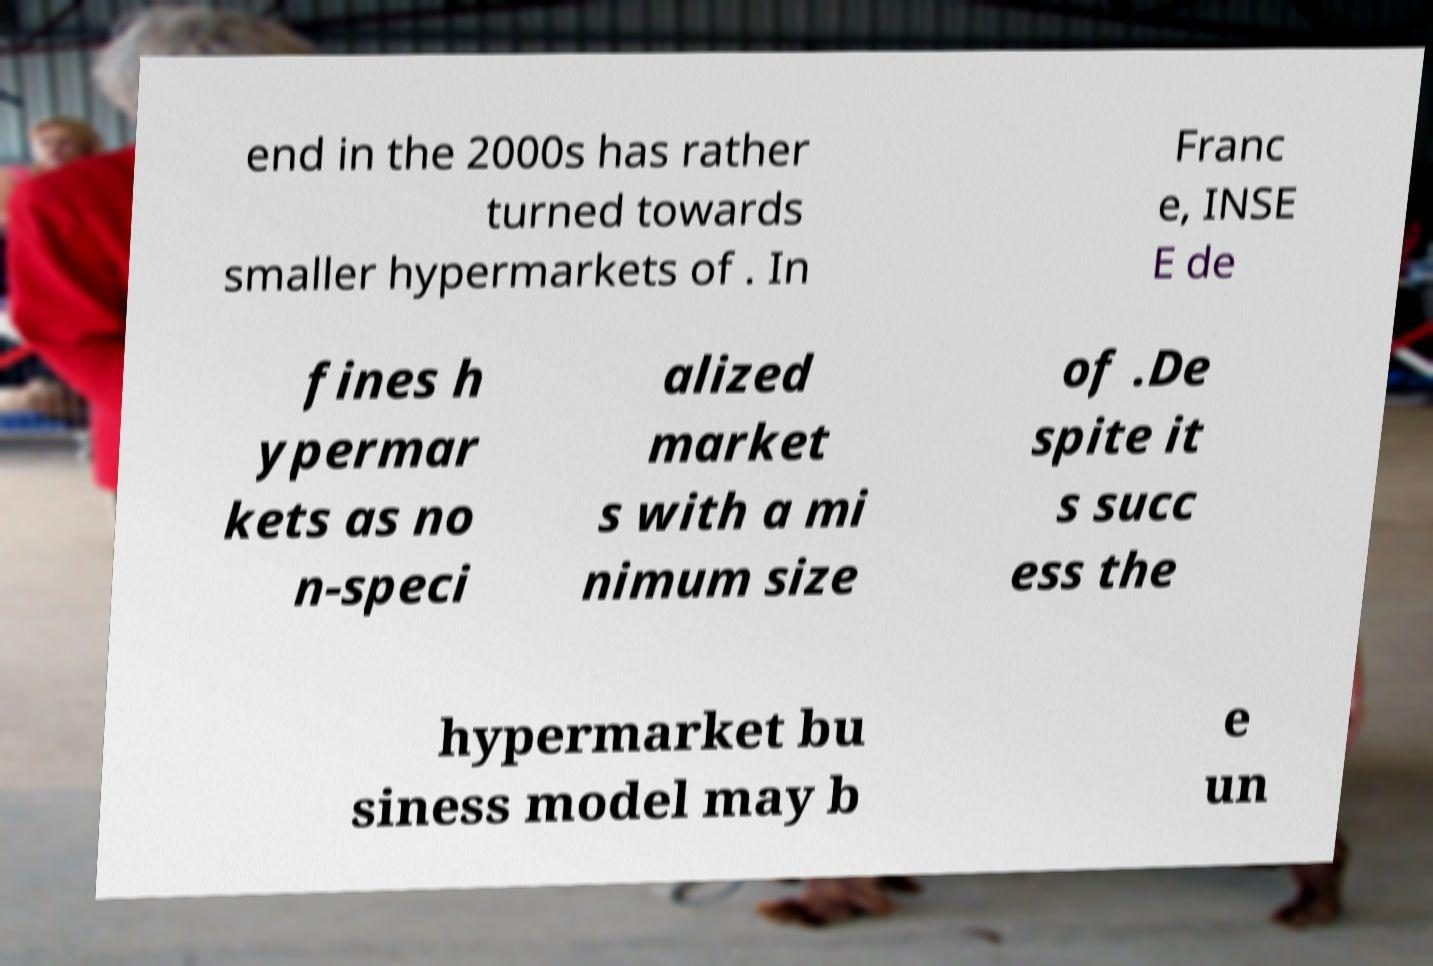Can you accurately transcribe the text from the provided image for me? end in the 2000s has rather turned towards smaller hypermarkets of . In Franc e, INSE E de fines h ypermar kets as no n-speci alized market s with a mi nimum size of .De spite it s succ ess the hypermarket bu siness model may b e un 